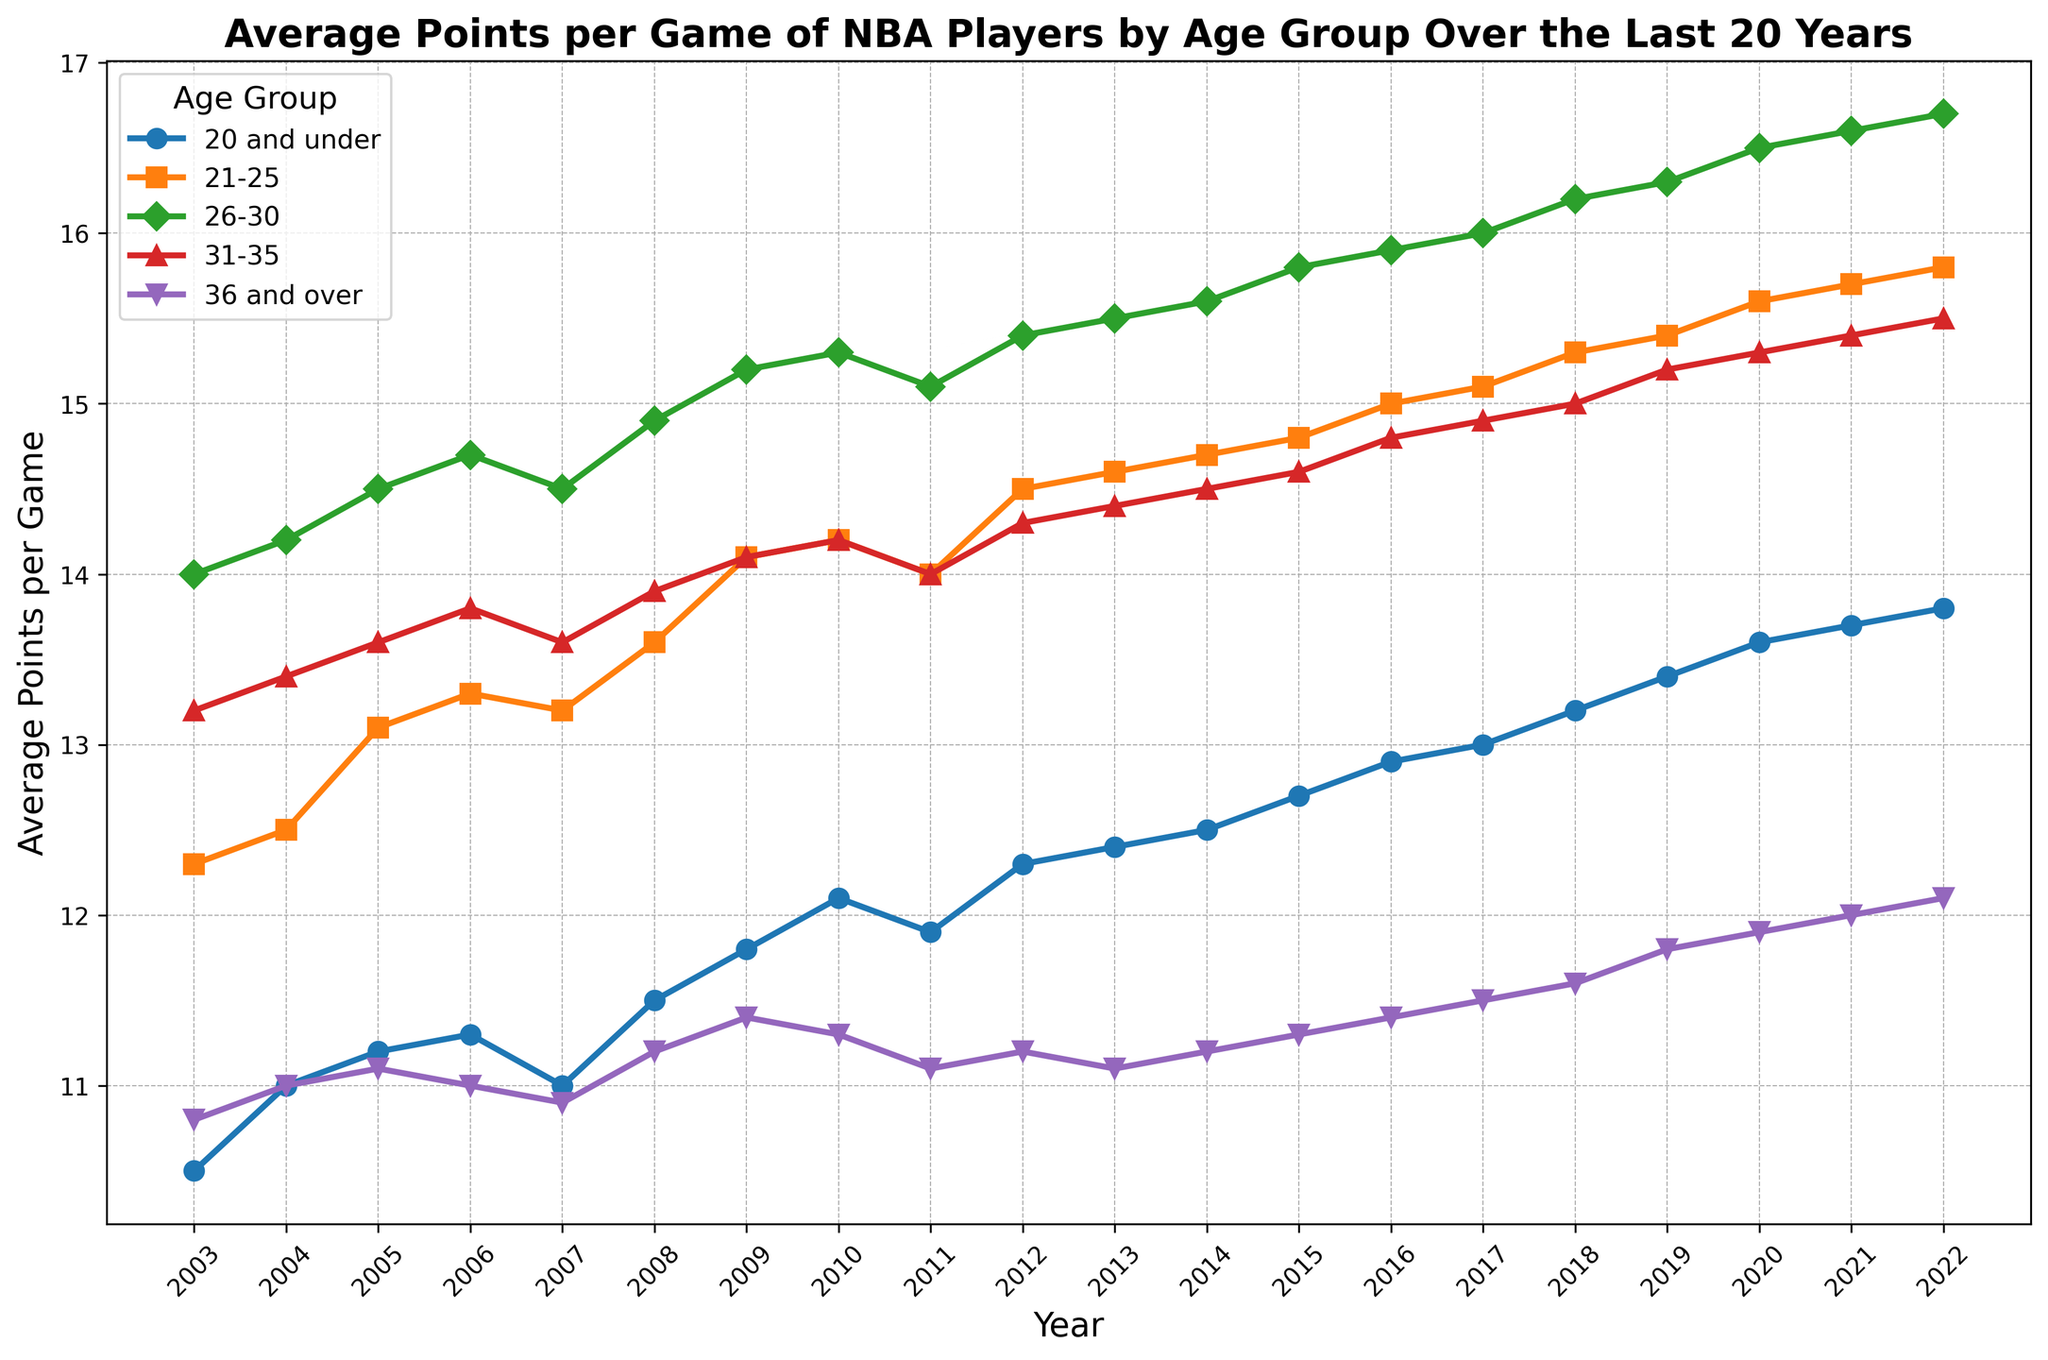How has the average points per game for the "20 and under" age group changed from 2003 to 2022? Look at the line for the "20 and under" age group on the graph. In 2003, the average points per game were 10.5, and in 2022, it was 13.8. Subtract the earlier value from the later value: 13.8 - 10.5 = 3.3.
Answer: It has increased by 3.3 points Which age group had the highest average points per game in 2017? Observe the graph for the year 2017. Find the line that is highest on the y-axis in that year. The "26-30" age group is highest in 2017, with 16.0 points per game.
Answer: 26-30 Did the "36 and over" age group ever surpass the "31-35" age group in average points per game over the years displayed? Compare the lines for the "36 and over" and "31-35" age groups. The "36 and over" age group never surpasses the "31-35" age group in any year. The "31-35" line is always above the "36 and over" line.
Answer: No In which year did the "21-25" age group see the highest increase in average points per game compared to the previous year? Look at the slope of the "21-25" line between each pair of consecutive years. The largest increase appears between 2010 and 2011, where the average points per game increases from 14.2 to 14.0 = 0.5 points.
Answer: 2011 What is the average points per game for the "26-30" age group over the 20-year period? Sum the average points per game for the "26-30" age group from 2003 to 2022 and divide by 20. (14.0 + 14.2 + 14.5 + 14.7 + 14.5 + 14.9 + 15.2 + 15.3 + 15.1 + 15.4 + 15.5 + 15.6 + 15.8 + 15.9 + 16.0 + 16.2 + 16.3 + 16.5 + 16.6 + 16.7) / 20 = 15.2.
Answer: 15.2 Between which consecutive years did the "31-35" age group experience the largest decline in average points per game? Check the slope of the "31-35" line between each pair of consecutive years to find the steepest negative slope. The largest decline is between 2006 (13.8) and 2007 (13.6), which is a decrease of 0.2 points.
Answer: 2006-2007 What trend do you observe in the average points per game for all age groups from 2003 to 2022? Look at the lines representing each age group over the years. All lines show an overall increasing trend in the average points per game from 2003 to 2022, indicating an overall increase in scoring over the years for all age groups.
Answer: Increasing trend Which age group shows the most consistent scoring pattern over the 20 years, with the least fluctuations? Identify the line with the least variation (smoothest, least ups and downs). The "36 and over" age group shows the most consistent pattern, with relatively small fluctuations compared to other groups.
Answer: 36 and over Compare the average points per game for the "20 and under" age group and "36 and over" age group in 2010. Which group performed better and by how much? Refer to the y-values for the "20 and under" and "36 and over" age groups in 2010. The "20 and under" group had 12.1 points per game, and the "36 and over" group had 11.3 points per game. The difference is 12.1 - 11.3 = 0.8 points.
Answer: 20 and under by 0.8 points 